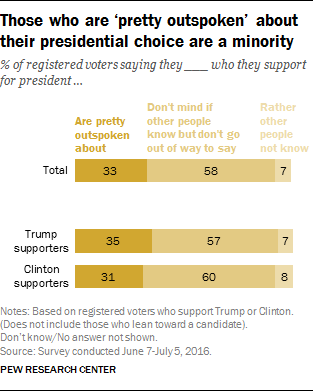Highlight a few significant elements in this photo. The leftmost bar in the middle is valued at 35. The values 7 and 8 are repeated in the bar. 